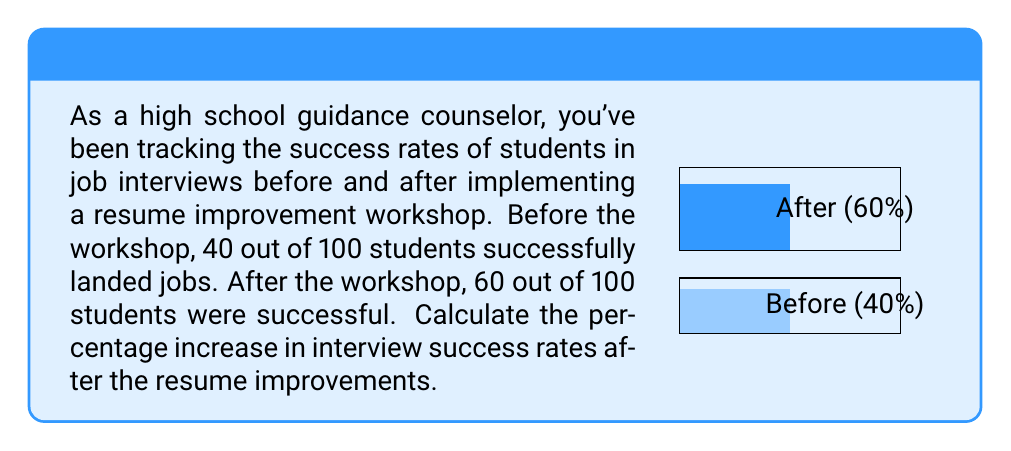Show me your answer to this math problem. To calculate the percentage increase in interview success rates, we'll follow these steps:

1) Calculate the initial success rate:
   $\text{Initial rate} = \frac{40}{100} = 0.40 = 40\%$

2) Calculate the new success rate:
   $\text{New rate} = \frac{60}{100} = 0.60 = 60\%$

3) Calculate the absolute increase:
   $\text{Absolute increase} = 60\% - 40\% = 20\%$

4) Calculate the relative increase:
   $$\text{Relative increase} = \frac{\text{Absolute increase}}{\text{Initial rate}} \times 100\%$$
   $$= \frac{20\%}{40\%} \times 100\% = 0.5 \times 100\% = 50\%$$

Therefore, the percentage increase in interview success rates is 50%.
Answer: 50% 